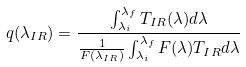Convert formula to latex. <formula><loc_0><loc_0><loc_500><loc_500>q ( \lambda _ { I R } ) = \frac { \int _ { \lambda _ { i } } ^ { \lambda _ { f } } T _ { I R } ( \lambda ) d \lambda } { \frac { 1 } { F ( \lambda _ { I R } ) } \int _ { \lambda _ { i } } ^ { \lambda _ { f } } F ( \lambda ) T _ { I R } d \lambda }</formula> 